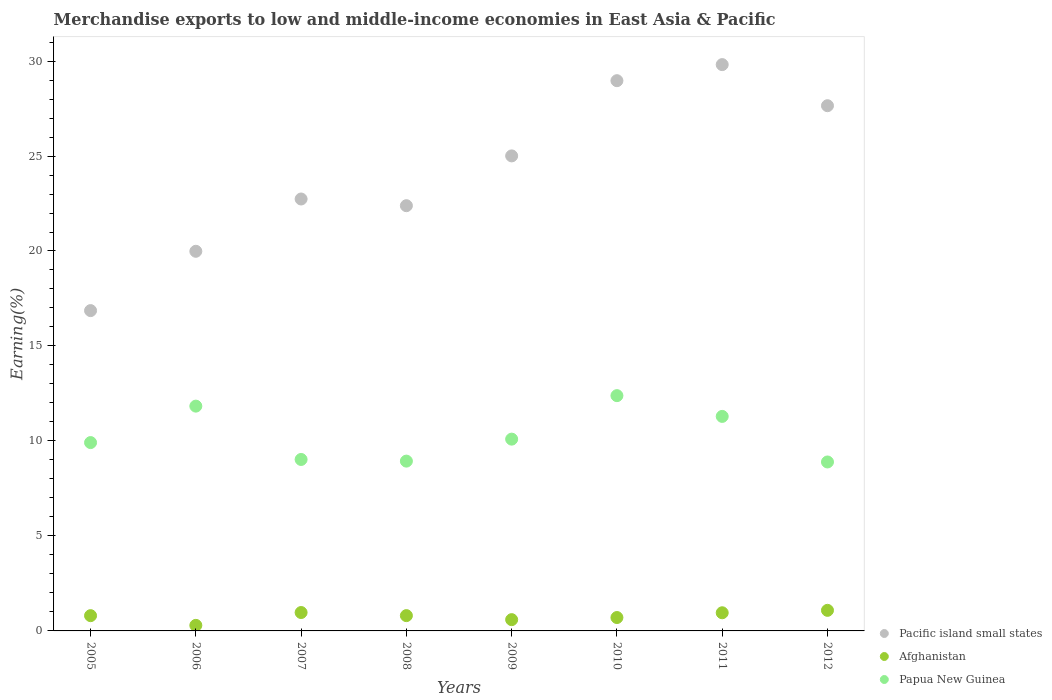How many different coloured dotlines are there?
Provide a succinct answer. 3. What is the percentage of amount earned from merchandise exports in Afghanistan in 2006?
Your answer should be very brief. 0.29. Across all years, what is the maximum percentage of amount earned from merchandise exports in Afghanistan?
Keep it short and to the point. 1.08. Across all years, what is the minimum percentage of amount earned from merchandise exports in Pacific island small states?
Make the answer very short. 16.86. In which year was the percentage of amount earned from merchandise exports in Papua New Guinea maximum?
Offer a terse response. 2010. In which year was the percentage of amount earned from merchandise exports in Afghanistan minimum?
Provide a short and direct response. 2006. What is the total percentage of amount earned from merchandise exports in Pacific island small states in the graph?
Your answer should be very brief. 193.4. What is the difference between the percentage of amount earned from merchandise exports in Pacific island small states in 2006 and that in 2009?
Ensure brevity in your answer.  -5.02. What is the difference between the percentage of amount earned from merchandise exports in Papua New Guinea in 2008 and the percentage of amount earned from merchandise exports in Pacific island small states in 2009?
Give a very brief answer. -16.07. What is the average percentage of amount earned from merchandise exports in Afghanistan per year?
Offer a terse response. 0.78. In the year 2007, what is the difference between the percentage of amount earned from merchandise exports in Afghanistan and percentage of amount earned from merchandise exports in Papua New Guinea?
Offer a terse response. -8.06. What is the ratio of the percentage of amount earned from merchandise exports in Papua New Guinea in 2006 to that in 2011?
Your answer should be very brief. 1.05. What is the difference between the highest and the second highest percentage of amount earned from merchandise exports in Pacific island small states?
Ensure brevity in your answer.  0.85. What is the difference between the highest and the lowest percentage of amount earned from merchandise exports in Pacific island small states?
Your response must be concise. 12.95. Is the sum of the percentage of amount earned from merchandise exports in Afghanistan in 2005 and 2010 greater than the maximum percentage of amount earned from merchandise exports in Papua New Guinea across all years?
Provide a succinct answer. No. Is it the case that in every year, the sum of the percentage of amount earned from merchandise exports in Afghanistan and percentage of amount earned from merchandise exports in Papua New Guinea  is greater than the percentage of amount earned from merchandise exports in Pacific island small states?
Provide a short and direct response. No. Does the percentage of amount earned from merchandise exports in Papua New Guinea monotonically increase over the years?
Your answer should be very brief. No. How many dotlines are there?
Provide a short and direct response. 3. How many years are there in the graph?
Provide a succinct answer. 8. Are the values on the major ticks of Y-axis written in scientific E-notation?
Offer a very short reply. No. Does the graph contain any zero values?
Offer a very short reply. No. Where does the legend appear in the graph?
Ensure brevity in your answer.  Bottom right. How many legend labels are there?
Offer a very short reply. 3. How are the legend labels stacked?
Your answer should be compact. Vertical. What is the title of the graph?
Give a very brief answer. Merchandise exports to low and middle-income economies in East Asia & Pacific. Does "Eritrea" appear as one of the legend labels in the graph?
Make the answer very short. No. What is the label or title of the X-axis?
Ensure brevity in your answer.  Years. What is the label or title of the Y-axis?
Ensure brevity in your answer.  Earning(%). What is the Earning(%) of Pacific island small states in 2005?
Provide a short and direct response. 16.86. What is the Earning(%) of Afghanistan in 2005?
Give a very brief answer. 0.8. What is the Earning(%) of Papua New Guinea in 2005?
Your response must be concise. 9.91. What is the Earning(%) in Pacific island small states in 2006?
Keep it short and to the point. 19.98. What is the Earning(%) in Afghanistan in 2006?
Provide a short and direct response. 0.29. What is the Earning(%) in Papua New Guinea in 2006?
Provide a short and direct response. 11.83. What is the Earning(%) in Pacific island small states in 2007?
Give a very brief answer. 22.74. What is the Earning(%) of Afghanistan in 2007?
Offer a very short reply. 0.97. What is the Earning(%) of Papua New Guinea in 2007?
Keep it short and to the point. 9.03. What is the Earning(%) of Pacific island small states in 2008?
Provide a short and direct response. 22.39. What is the Earning(%) of Afghanistan in 2008?
Keep it short and to the point. 0.81. What is the Earning(%) in Papua New Guinea in 2008?
Your response must be concise. 8.94. What is the Earning(%) in Pacific island small states in 2009?
Make the answer very short. 25.01. What is the Earning(%) of Afghanistan in 2009?
Give a very brief answer. 0.59. What is the Earning(%) of Papua New Guinea in 2009?
Ensure brevity in your answer.  10.1. What is the Earning(%) of Pacific island small states in 2010?
Make the answer very short. 28.97. What is the Earning(%) of Afghanistan in 2010?
Your response must be concise. 0.7. What is the Earning(%) of Papua New Guinea in 2010?
Provide a short and direct response. 12.39. What is the Earning(%) in Pacific island small states in 2011?
Make the answer very short. 29.81. What is the Earning(%) in Afghanistan in 2011?
Make the answer very short. 0.96. What is the Earning(%) in Papua New Guinea in 2011?
Offer a terse response. 11.29. What is the Earning(%) of Pacific island small states in 2012?
Make the answer very short. 27.65. What is the Earning(%) in Afghanistan in 2012?
Ensure brevity in your answer.  1.08. What is the Earning(%) in Papua New Guinea in 2012?
Your response must be concise. 8.89. Across all years, what is the maximum Earning(%) in Pacific island small states?
Your response must be concise. 29.81. Across all years, what is the maximum Earning(%) in Afghanistan?
Make the answer very short. 1.08. Across all years, what is the maximum Earning(%) in Papua New Guinea?
Your answer should be very brief. 12.39. Across all years, what is the minimum Earning(%) of Pacific island small states?
Give a very brief answer. 16.86. Across all years, what is the minimum Earning(%) in Afghanistan?
Give a very brief answer. 0.29. Across all years, what is the minimum Earning(%) in Papua New Guinea?
Give a very brief answer. 8.89. What is the total Earning(%) of Pacific island small states in the graph?
Keep it short and to the point. 193.4. What is the total Earning(%) in Afghanistan in the graph?
Make the answer very short. 6.21. What is the total Earning(%) in Papua New Guinea in the graph?
Your response must be concise. 82.38. What is the difference between the Earning(%) of Pacific island small states in 2005 and that in 2006?
Offer a terse response. -3.12. What is the difference between the Earning(%) in Afghanistan in 2005 and that in 2006?
Offer a very short reply. 0.51. What is the difference between the Earning(%) of Papua New Guinea in 2005 and that in 2006?
Make the answer very short. -1.92. What is the difference between the Earning(%) in Pacific island small states in 2005 and that in 2007?
Offer a very short reply. -5.88. What is the difference between the Earning(%) of Afghanistan in 2005 and that in 2007?
Keep it short and to the point. -0.16. What is the difference between the Earning(%) in Papua New Guinea in 2005 and that in 2007?
Your answer should be compact. 0.89. What is the difference between the Earning(%) in Pacific island small states in 2005 and that in 2008?
Offer a terse response. -5.52. What is the difference between the Earning(%) in Afghanistan in 2005 and that in 2008?
Offer a terse response. -0. What is the difference between the Earning(%) in Papua New Guinea in 2005 and that in 2008?
Your answer should be very brief. 0.98. What is the difference between the Earning(%) in Pacific island small states in 2005 and that in 2009?
Your response must be concise. -8.14. What is the difference between the Earning(%) of Afghanistan in 2005 and that in 2009?
Provide a succinct answer. 0.21. What is the difference between the Earning(%) of Papua New Guinea in 2005 and that in 2009?
Ensure brevity in your answer.  -0.18. What is the difference between the Earning(%) of Pacific island small states in 2005 and that in 2010?
Your response must be concise. -12.1. What is the difference between the Earning(%) of Afghanistan in 2005 and that in 2010?
Offer a very short reply. 0.1. What is the difference between the Earning(%) in Papua New Guinea in 2005 and that in 2010?
Ensure brevity in your answer.  -2.47. What is the difference between the Earning(%) in Pacific island small states in 2005 and that in 2011?
Your answer should be very brief. -12.95. What is the difference between the Earning(%) in Afghanistan in 2005 and that in 2011?
Give a very brief answer. -0.15. What is the difference between the Earning(%) in Papua New Guinea in 2005 and that in 2011?
Make the answer very short. -1.38. What is the difference between the Earning(%) of Pacific island small states in 2005 and that in 2012?
Offer a terse response. -10.79. What is the difference between the Earning(%) in Afghanistan in 2005 and that in 2012?
Your answer should be very brief. -0.28. What is the difference between the Earning(%) of Papua New Guinea in 2005 and that in 2012?
Make the answer very short. 1.02. What is the difference between the Earning(%) in Pacific island small states in 2006 and that in 2007?
Make the answer very short. -2.75. What is the difference between the Earning(%) of Afghanistan in 2006 and that in 2007?
Provide a succinct answer. -0.68. What is the difference between the Earning(%) in Papua New Guinea in 2006 and that in 2007?
Your answer should be compact. 2.81. What is the difference between the Earning(%) in Pacific island small states in 2006 and that in 2008?
Your response must be concise. -2.4. What is the difference between the Earning(%) of Afghanistan in 2006 and that in 2008?
Your response must be concise. -0.51. What is the difference between the Earning(%) of Papua New Guinea in 2006 and that in 2008?
Give a very brief answer. 2.89. What is the difference between the Earning(%) of Pacific island small states in 2006 and that in 2009?
Offer a very short reply. -5.02. What is the difference between the Earning(%) of Afghanistan in 2006 and that in 2009?
Make the answer very short. -0.3. What is the difference between the Earning(%) of Papua New Guinea in 2006 and that in 2009?
Offer a very short reply. 1.74. What is the difference between the Earning(%) of Pacific island small states in 2006 and that in 2010?
Ensure brevity in your answer.  -8.98. What is the difference between the Earning(%) in Afghanistan in 2006 and that in 2010?
Give a very brief answer. -0.41. What is the difference between the Earning(%) of Papua New Guinea in 2006 and that in 2010?
Your response must be concise. -0.55. What is the difference between the Earning(%) in Pacific island small states in 2006 and that in 2011?
Ensure brevity in your answer.  -9.83. What is the difference between the Earning(%) of Afghanistan in 2006 and that in 2011?
Your answer should be compact. -0.66. What is the difference between the Earning(%) of Papua New Guinea in 2006 and that in 2011?
Give a very brief answer. 0.54. What is the difference between the Earning(%) in Pacific island small states in 2006 and that in 2012?
Your answer should be compact. -7.66. What is the difference between the Earning(%) of Afghanistan in 2006 and that in 2012?
Make the answer very short. -0.79. What is the difference between the Earning(%) in Papua New Guinea in 2006 and that in 2012?
Provide a short and direct response. 2.94. What is the difference between the Earning(%) of Pacific island small states in 2007 and that in 2008?
Offer a very short reply. 0.35. What is the difference between the Earning(%) in Afghanistan in 2007 and that in 2008?
Make the answer very short. 0.16. What is the difference between the Earning(%) of Papua New Guinea in 2007 and that in 2008?
Ensure brevity in your answer.  0.09. What is the difference between the Earning(%) of Pacific island small states in 2007 and that in 2009?
Provide a succinct answer. -2.27. What is the difference between the Earning(%) in Afghanistan in 2007 and that in 2009?
Your response must be concise. 0.37. What is the difference between the Earning(%) in Papua New Guinea in 2007 and that in 2009?
Make the answer very short. -1.07. What is the difference between the Earning(%) of Pacific island small states in 2007 and that in 2010?
Provide a short and direct response. -6.23. What is the difference between the Earning(%) in Afghanistan in 2007 and that in 2010?
Provide a succinct answer. 0.26. What is the difference between the Earning(%) in Papua New Guinea in 2007 and that in 2010?
Your answer should be very brief. -3.36. What is the difference between the Earning(%) in Pacific island small states in 2007 and that in 2011?
Give a very brief answer. -7.07. What is the difference between the Earning(%) of Afghanistan in 2007 and that in 2011?
Give a very brief answer. 0.01. What is the difference between the Earning(%) in Papua New Guinea in 2007 and that in 2011?
Provide a short and direct response. -2.27. What is the difference between the Earning(%) of Pacific island small states in 2007 and that in 2012?
Provide a short and direct response. -4.91. What is the difference between the Earning(%) of Afghanistan in 2007 and that in 2012?
Your answer should be very brief. -0.12. What is the difference between the Earning(%) of Papua New Guinea in 2007 and that in 2012?
Make the answer very short. 0.13. What is the difference between the Earning(%) in Pacific island small states in 2008 and that in 2009?
Provide a succinct answer. -2.62. What is the difference between the Earning(%) of Afghanistan in 2008 and that in 2009?
Your answer should be very brief. 0.21. What is the difference between the Earning(%) of Papua New Guinea in 2008 and that in 2009?
Make the answer very short. -1.16. What is the difference between the Earning(%) of Pacific island small states in 2008 and that in 2010?
Your answer should be compact. -6.58. What is the difference between the Earning(%) of Afghanistan in 2008 and that in 2010?
Ensure brevity in your answer.  0.1. What is the difference between the Earning(%) of Papua New Guinea in 2008 and that in 2010?
Keep it short and to the point. -3.45. What is the difference between the Earning(%) in Pacific island small states in 2008 and that in 2011?
Offer a very short reply. -7.43. What is the difference between the Earning(%) of Afghanistan in 2008 and that in 2011?
Your answer should be very brief. -0.15. What is the difference between the Earning(%) of Papua New Guinea in 2008 and that in 2011?
Ensure brevity in your answer.  -2.35. What is the difference between the Earning(%) of Pacific island small states in 2008 and that in 2012?
Keep it short and to the point. -5.26. What is the difference between the Earning(%) of Afghanistan in 2008 and that in 2012?
Keep it short and to the point. -0.28. What is the difference between the Earning(%) of Papua New Guinea in 2008 and that in 2012?
Provide a short and direct response. 0.04. What is the difference between the Earning(%) of Pacific island small states in 2009 and that in 2010?
Your answer should be compact. -3.96. What is the difference between the Earning(%) in Afghanistan in 2009 and that in 2010?
Your answer should be very brief. -0.11. What is the difference between the Earning(%) in Papua New Guinea in 2009 and that in 2010?
Ensure brevity in your answer.  -2.29. What is the difference between the Earning(%) in Pacific island small states in 2009 and that in 2011?
Ensure brevity in your answer.  -4.81. What is the difference between the Earning(%) of Afghanistan in 2009 and that in 2011?
Provide a short and direct response. -0.36. What is the difference between the Earning(%) of Papua New Guinea in 2009 and that in 2011?
Offer a terse response. -1.2. What is the difference between the Earning(%) of Pacific island small states in 2009 and that in 2012?
Your answer should be very brief. -2.64. What is the difference between the Earning(%) in Afghanistan in 2009 and that in 2012?
Your response must be concise. -0.49. What is the difference between the Earning(%) of Papua New Guinea in 2009 and that in 2012?
Keep it short and to the point. 1.2. What is the difference between the Earning(%) of Pacific island small states in 2010 and that in 2011?
Offer a terse response. -0.85. What is the difference between the Earning(%) in Afghanistan in 2010 and that in 2011?
Make the answer very short. -0.25. What is the difference between the Earning(%) in Papua New Guinea in 2010 and that in 2011?
Offer a very short reply. 1.09. What is the difference between the Earning(%) of Pacific island small states in 2010 and that in 2012?
Offer a terse response. 1.32. What is the difference between the Earning(%) in Afghanistan in 2010 and that in 2012?
Offer a terse response. -0.38. What is the difference between the Earning(%) of Papua New Guinea in 2010 and that in 2012?
Your response must be concise. 3.49. What is the difference between the Earning(%) in Pacific island small states in 2011 and that in 2012?
Give a very brief answer. 2.16. What is the difference between the Earning(%) in Afghanistan in 2011 and that in 2012?
Your response must be concise. -0.13. What is the difference between the Earning(%) in Papua New Guinea in 2011 and that in 2012?
Provide a succinct answer. 2.4. What is the difference between the Earning(%) in Pacific island small states in 2005 and the Earning(%) in Afghanistan in 2006?
Your answer should be very brief. 16.57. What is the difference between the Earning(%) in Pacific island small states in 2005 and the Earning(%) in Papua New Guinea in 2006?
Provide a succinct answer. 5.03. What is the difference between the Earning(%) in Afghanistan in 2005 and the Earning(%) in Papua New Guinea in 2006?
Offer a very short reply. -11.03. What is the difference between the Earning(%) in Pacific island small states in 2005 and the Earning(%) in Afghanistan in 2007?
Make the answer very short. 15.89. What is the difference between the Earning(%) of Pacific island small states in 2005 and the Earning(%) of Papua New Guinea in 2007?
Give a very brief answer. 7.84. What is the difference between the Earning(%) of Afghanistan in 2005 and the Earning(%) of Papua New Guinea in 2007?
Give a very brief answer. -8.22. What is the difference between the Earning(%) of Pacific island small states in 2005 and the Earning(%) of Afghanistan in 2008?
Keep it short and to the point. 16.06. What is the difference between the Earning(%) in Pacific island small states in 2005 and the Earning(%) in Papua New Guinea in 2008?
Your answer should be compact. 7.92. What is the difference between the Earning(%) of Afghanistan in 2005 and the Earning(%) of Papua New Guinea in 2008?
Offer a terse response. -8.14. What is the difference between the Earning(%) in Pacific island small states in 2005 and the Earning(%) in Afghanistan in 2009?
Your response must be concise. 16.27. What is the difference between the Earning(%) of Pacific island small states in 2005 and the Earning(%) of Papua New Guinea in 2009?
Ensure brevity in your answer.  6.77. What is the difference between the Earning(%) in Afghanistan in 2005 and the Earning(%) in Papua New Guinea in 2009?
Give a very brief answer. -9.29. What is the difference between the Earning(%) of Pacific island small states in 2005 and the Earning(%) of Afghanistan in 2010?
Your response must be concise. 16.16. What is the difference between the Earning(%) of Pacific island small states in 2005 and the Earning(%) of Papua New Guinea in 2010?
Provide a short and direct response. 4.48. What is the difference between the Earning(%) of Afghanistan in 2005 and the Earning(%) of Papua New Guinea in 2010?
Keep it short and to the point. -11.58. What is the difference between the Earning(%) in Pacific island small states in 2005 and the Earning(%) in Afghanistan in 2011?
Provide a short and direct response. 15.91. What is the difference between the Earning(%) of Pacific island small states in 2005 and the Earning(%) of Papua New Guinea in 2011?
Offer a terse response. 5.57. What is the difference between the Earning(%) in Afghanistan in 2005 and the Earning(%) in Papua New Guinea in 2011?
Keep it short and to the point. -10.49. What is the difference between the Earning(%) of Pacific island small states in 2005 and the Earning(%) of Afghanistan in 2012?
Your response must be concise. 15.78. What is the difference between the Earning(%) of Pacific island small states in 2005 and the Earning(%) of Papua New Guinea in 2012?
Your answer should be compact. 7.97. What is the difference between the Earning(%) in Afghanistan in 2005 and the Earning(%) in Papua New Guinea in 2012?
Give a very brief answer. -8.09. What is the difference between the Earning(%) in Pacific island small states in 2006 and the Earning(%) in Afghanistan in 2007?
Offer a very short reply. 19.02. What is the difference between the Earning(%) of Pacific island small states in 2006 and the Earning(%) of Papua New Guinea in 2007?
Your answer should be very brief. 10.96. What is the difference between the Earning(%) of Afghanistan in 2006 and the Earning(%) of Papua New Guinea in 2007?
Your response must be concise. -8.73. What is the difference between the Earning(%) in Pacific island small states in 2006 and the Earning(%) in Afghanistan in 2008?
Offer a very short reply. 19.18. What is the difference between the Earning(%) in Pacific island small states in 2006 and the Earning(%) in Papua New Guinea in 2008?
Keep it short and to the point. 11.05. What is the difference between the Earning(%) of Afghanistan in 2006 and the Earning(%) of Papua New Guinea in 2008?
Provide a short and direct response. -8.65. What is the difference between the Earning(%) of Pacific island small states in 2006 and the Earning(%) of Afghanistan in 2009?
Ensure brevity in your answer.  19.39. What is the difference between the Earning(%) of Pacific island small states in 2006 and the Earning(%) of Papua New Guinea in 2009?
Your answer should be compact. 9.89. What is the difference between the Earning(%) of Afghanistan in 2006 and the Earning(%) of Papua New Guinea in 2009?
Ensure brevity in your answer.  -9.8. What is the difference between the Earning(%) in Pacific island small states in 2006 and the Earning(%) in Afghanistan in 2010?
Offer a very short reply. 19.28. What is the difference between the Earning(%) of Pacific island small states in 2006 and the Earning(%) of Papua New Guinea in 2010?
Give a very brief answer. 7.6. What is the difference between the Earning(%) of Afghanistan in 2006 and the Earning(%) of Papua New Guinea in 2010?
Offer a terse response. -12.09. What is the difference between the Earning(%) in Pacific island small states in 2006 and the Earning(%) in Afghanistan in 2011?
Your response must be concise. 19.03. What is the difference between the Earning(%) of Pacific island small states in 2006 and the Earning(%) of Papua New Guinea in 2011?
Your answer should be compact. 8.69. What is the difference between the Earning(%) of Afghanistan in 2006 and the Earning(%) of Papua New Guinea in 2011?
Offer a very short reply. -11. What is the difference between the Earning(%) in Pacific island small states in 2006 and the Earning(%) in Afghanistan in 2012?
Provide a short and direct response. 18.9. What is the difference between the Earning(%) in Pacific island small states in 2006 and the Earning(%) in Papua New Guinea in 2012?
Offer a terse response. 11.09. What is the difference between the Earning(%) in Afghanistan in 2006 and the Earning(%) in Papua New Guinea in 2012?
Provide a short and direct response. -8.6. What is the difference between the Earning(%) of Pacific island small states in 2007 and the Earning(%) of Afghanistan in 2008?
Ensure brevity in your answer.  21.93. What is the difference between the Earning(%) in Pacific island small states in 2007 and the Earning(%) in Papua New Guinea in 2008?
Provide a short and direct response. 13.8. What is the difference between the Earning(%) in Afghanistan in 2007 and the Earning(%) in Papua New Guinea in 2008?
Ensure brevity in your answer.  -7.97. What is the difference between the Earning(%) of Pacific island small states in 2007 and the Earning(%) of Afghanistan in 2009?
Give a very brief answer. 22.14. What is the difference between the Earning(%) in Pacific island small states in 2007 and the Earning(%) in Papua New Guinea in 2009?
Offer a very short reply. 12.64. What is the difference between the Earning(%) of Afghanistan in 2007 and the Earning(%) of Papua New Guinea in 2009?
Your answer should be compact. -9.13. What is the difference between the Earning(%) in Pacific island small states in 2007 and the Earning(%) in Afghanistan in 2010?
Offer a very short reply. 22.03. What is the difference between the Earning(%) in Pacific island small states in 2007 and the Earning(%) in Papua New Guinea in 2010?
Provide a succinct answer. 10.35. What is the difference between the Earning(%) of Afghanistan in 2007 and the Earning(%) of Papua New Guinea in 2010?
Make the answer very short. -11.42. What is the difference between the Earning(%) of Pacific island small states in 2007 and the Earning(%) of Afghanistan in 2011?
Ensure brevity in your answer.  21.78. What is the difference between the Earning(%) of Pacific island small states in 2007 and the Earning(%) of Papua New Guinea in 2011?
Offer a very short reply. 11.44. What is the difference between the Earning(%) of Afghanistan in 2007 and the Earning(%) of Papua New Guinea in 2011?
Provide a short and direct response. -10.32. What is the difference between the Earning(%) of Pacific island small states in 2007 and the Earning(%) of Afghanistan in 2012?
Your response must be concise. 21.65. What is the difference between the Earning(%) of Pacific island small states in 2007 and the Earning(%) of Papua New Guinea in 2012?
Provide a succinct answer. 13.84. What is the difference between the Earning(%) in Afghanistan in 2007 and the Earning(%) in Papua New Guinea in 2012?
Offer a very short reply. -7.93. What is the difference between the Earning(%) of Pacific island small states in 2008 and the Earning(%) of Afghanistan in 2009?
Give a very brief answer. 21.79. What is the difference between the Earning(%) in Pacific island small states in 2008 and the Earning(%) in Papua New Guinea in 2009?
Provide a short and direct response. 12.29. What is the difference between the Earning(%) in Afghanistan in 2008 and the Earning(%) in Papua New Guinea in 2009?
Ensure brevity in your answer.  -9.29. What is the difference between the Earning(%) of Pacific island small states in 2008 and the Earning(%) of Afghanistan in 2010?
Offer a terse response. 21.68. What is the difference between the Earning(%) in Pacific island small states in 2008 and the Earning(%) in Papua New Guinea in 2010?
Offer a terse response. 10. What is the difference between the Earning(%) of Afghanistan in 2008 and the Earning(%) of Papua New Guinea in 2010?
Provide a short and direct response. -11.58. What is the difference between the Earning(%) in Pacific island small states in 2008 and the Earning(%) in Afghanistan in 2011?
Ensure brevity in your answer.  21.43. What is the difference between the Earning(%) of Pacific island small states in 2008 and the Earning(%) of Papua New Guinea in 2011?
Your answer should be very brief. 11.09. What is the difference between the Earning(%) of Afghanistan in 2008 and the Earning(%) of Papua New Guinea in 2011?
Offer a very short reply. -10.49. What is the difference between the Earning(%) of Pacific island small states in 2008 and the Earning(%) of Afghanistan in 2012?
Offer a terse response. 21.3. What is the difference between the Earning(%) of Pacific island small states in 2008 and the Earning(%) of Papua New Guinea in 2012?
Provide a succinct answer. 13.49. What is the difference between the Earning(%) of Afghanistan in 2008 and the Earning(%) of Papua New Guinea in 2012?
Offer a very short reply. -8.09. What is the difference between the Earning(%) of Pacific island small states in 2009 and the Earning(%) of Afghanistan in 2010?
Your answer should be compact. 24.3. What is the difference between the Earning(%) in Pacific island small states in 2009 and the Earning(%) in Papua New Guinea in 2010?
Keep it short and to the point. 12.62. What is the difference between the Earning(%) in Afghanistan in 2009 and the Earning(%) in Papua New Guinea in 2010?
Your response must be concise. -11.79. What is the difference between the Earning(%) of Pacific island small states in 2009 and the Earning(%) of Afghanistan in 2011?
Your answer should be very brief. 24.05. What is the difference between the Earning(%) of Pacific island small states in 2009 and the Earning(%) of Papua New Guinea in 2011?
Ensure brevity in your answer.  13.71. What is the difference between the Earning(%) of Afghanistan in 2009 and the Earning(%) of Papua New Guinea in 2011?
Your response must be concise. -10.7. What is the difference between the Earning(%) in Pacific island small states in 2009 and the Earning(%) in Afghanistan in 2012?
Make the answer very short. 23.92. What is the difference between the Earning(%) in Pacific island small states in 2009 and the Earning(%) in Papua New Guinea in 2012?
Offer a very short reply. 16.11. What is the difference between the Earning(%) in Afghanistan in 2009 and the Earning(%) in Papua New Guinea in 2012?
Offer a very short reply. -8.3. What is the difference between the Earning(%) in Pacific island small states in 2010 and the Earning(%) in Afghanistan in 2011?
Make the answer very short. 28.01. What is the difference between the Earning(%) of Pacific island small states in 2010 and the Earning(%) of Papua New Guinea in 2011?
Make the answer very short. 17.67. What is the difference between the Earning(%) in Afghanistan in 2010 and the Earning(%) in Papua New Guinea in 2011?
Keep it short and to the point. -10.59. What is the difference between the Earning(%) in Pacific island small states in 2010 and the Earning(%) in Afghanistan in 2012?
Give a very brief answer. 27.88. What is the difference between the Earning(%) of Pacific island small states in 2010 and the Earning(%) of Papua New Guinea in 2012?
Make the answer very short. 20.07. What is the difference between the Earning(%) of Afghanistan in 2010 and the Earning(%) of Papua New Guinea in 2012?
Give a very brief answer. -8.19. What is the difference between the Earning(%) of Pacific island small states in 2011 and the Earning(%) of Afghanistan in 2012?
Your answer should be very brief. 28.73. What is the difference between the Earning(%) in Pacific island small states in 2011 and the Earning(%) in Papua New Guinea in 2012?
Ensure brevity in your answer.  20.92. What is the difference between the Earning(%) in Afghanistan in 2011 and the Earning(%) in Papua New Guinea in 2012?
Your answer should be compact. -7.94. What is the average Earning(%) in Pacific island small states per year?
Your answer should be compact. 24.18. What is the average Earning(%) of Afghanistan per year?
Ensure brevity in your answer.  0.78. What is the average Earning(%) of Papua New Guinea per year?
Your response must be concise. 10.3. In the year 2005, what is the difference between the Earning(%) in Pacific island small states and Earning(%) in Afghanistan?
Ensure brevity in your answer.  16.06. In the year 2005, what is the difference between the Earning(%) of Pacific island small states and Earning(%) of Papua New Guinea?
Give a very brief answer. 6.95. In the year 2005, what is the difference between the Earning(%) in Afghanistan and Earning(%) in Papua New Guinea?
Offer a terse response. -9.11. In the year 2006, what is the difference between the Earning(%) of Pacific island small states and Earning(%) of Afghanistan?
Give a very brief answer. 19.69. In the year 2006, what is the difference between the Earning(%) in Pacific island small states and Earning(%) in Papua New Guinea?
Give a very brief answer. 8.15. In the year 2006, what is the difference between the Earning(%) in Afghanistan and Earning(%) in Papua New Guinea?
Keep it short and to the point. -11.54. In the year 2007, what is the difference between the Earning(%) of Pacific island small states and Earning(%) of Afghanistan?
Keep it short and to the point. 21.77. In the year 2007, what is the difference between the Earning(%) of Pacific island small states and Earning(%) of Papua New Guinea?
Your answer should be very brief. 13.71. In the year 2007, what is the difference between the Earning(%) in Afghanistan and Earning(%) in Papua New Guinea?
Give a very brief answer. -8.06. In the year 2008, what is the difference between the Earning(%) of Pacific island small states and Earning(%) of Afghanistan?
Keep it short and to the point. 21.58. In the year 2008, what is the difference between the Earning(%) of Pacific island small states and Earning(%) of Papua New Guinea?
Your response must be concise. 13.45. In the year 2008, what is the difference between the Earning(%) of Afghanistan and Earning(%) of Papua New Guinea?
Give a very brief answer. -8.13. In the year 2009, what is the difference between the Earning(%) of Pacific island small states and Earning(%) of Afghanistan?
Provide a succinct answer. 24.41. In the year 2009, what is the difference between the Earning(%) of Pacific island small states and Earning(%) of Papua New Guinea?
Your answer should be very brief. 14.91. In the year 2009, what is the difference between the Earning(%) of Afghanistan and Earning(%) of Papua New Guinea?
Make the answer very short. -9.5. In the year 2010, what is the difference between the Earning(%) of Pacific island small states and Earning(%) of Afghanistan?
Keep it short and to the point. 28.26. In the year 2010, what is the difference between the Earning(%) of Pacific island small states and Earning(%) of Papua New Guinea?
Give a very brief answer. 16.58. In the year 2010, what is the difference between the Earning(%) in Afghanistan and Earning(%) in Papua New Guinea?
Offer a very short reply. -11.68. In the year 2011, what is the difference between the Earning(%) of Pacific island small states and Earning(%) of Afghanistan?
Give a very brief answer. 28.86. In the year 2011, what is the difference between the Earning(%) of Pacific island small states and Earning(%) of Papua New Guinea?
Provide a short and direct response. 18.52. In the year 2011, what is the difference between the Earning(%) in Afghanistan and Earning(%) in Papua New Guinea?
Provide a succinct answer. -10.34. In the year 2012, what is the difference between the Earning(%) in Pacific island small states and Earning(%) in Afghanistan?
Your answer should be compact. 26.57. In the year 2012, what is the difference between the Earning(%) in Pacific island small states and Earning(%) in Papua New Guinea?
Offer a very short reply. 18.75. In the year 2012, what is the difference between the Earning(%) of Afghanistan and Earning(%) of Papua New Guinea?
Your answer should be compact. -7.81. What is the ratio of the Earning(%) of Pacific island small states in 2005 to that in 2006?
Ensure brevity in your answer.  0.84. What is the ratio of the Earning(%) in Afghanistan in 2005 to that in 2006?
Keep it short and to the point. 2.74. What is the ratio of the Earning(%) in Papua New Guinea in 2005 to that in 2006?
Provide a short and direct response. 0.84. What is the ratio of the Earning(%) of Pacific island small states in 2005 to that in 2007?
Your response must be concise. 0.74. What is the ratio of the Earning(%) of Afghanistan in 2005 to that in 2007?
Ensure brevity in your answer.  0.83. What is the ratio of the Earning(%) of Papua New Guinea in 2005 to that in 2007?
Your answer should be compact. 1.1. What is the ratio of the Earning(%) in Pacific island small states in 2005 to that in 2008?
Keep it short and to the point. 0.75. What is the ratio of the Earning(%) of Papua New Guinea in 2005 to that in 2008?
Your answer should be compact. 1.11. What is the ratio of the Earning(%) in Pacific island small states in 2005 to that in 2009?
Make the answer very short. 0.67. What is the ratio of the Earning(%) in Afghanistan in 2005 to that in 2009?
Your response must be concise. 1.35. What is the ratio of the Earning(%) in Pacific island small states in 2005 to that in 2010?
Your answer should be very brief. 0.58. What is the ratio of the Earning(%) of Afghanistan in 2005 to that in 2010?
Offer a very short reply. 1.14. What is the ratio of the Earning(%) in Papua New Guinea in 2005 to that in 2010?
Offer a terse response. 0.8. What is the ratio of the Earning(%) in Pacific island small states in 2005 to that in 2011?
Ensure brevity in your answer.  0.57. What is the ratio of the Earning(%) in Afghanistan in 2005 to that in 2011?
Make the answer very short. 0.84. What is the ratio of the Earning(%) of Papua New Guinea in 2005 to that in 2011?
Provide a short and direct response. 0.88. What is the ratio of the Earning(%) of Pacific island small states in 2005 to that in 2012?
Make the answer very short. 0.61. What is the ratio of the Earning(%) of Afghanistan in 2005 to that in 2012?
Ensure brevity in your answer.  0.74. What is the ratio of the Earning(%) in Papua New Guinea in 2005 to that in 2012?
Your answer should be very brief. 1.11. What is the ratio of the Earning(%) of Pacific island small states in 2006 to that in 2007?
Provide a short and direct response. 0.88. What is the ratio of the Earning(%) of Afghanistan in 2006 to that in 2007?
Give a very brief answer. 0.3. What is the ratio of the Earning(%) in Papua New Guinea in 2006 to that in 2007?
Your response must be concise. 1.31. What is the ratio of the Earning(%) in Pacific island small states in 2006 to that in 2008?
Provide a short and direct response. 0.89. What is the ratio of the Earning(%) in Afghanistan in 2006 to that in 2008?
Your answer should be compact. 0.36. What is the ratio of the Earning(%) of Papua New Guinea in 2006 to that in 2008?
Make the answer very short. 1.32. What is the ratio of the Earning(%) in Pacific island small states in 2006 to that in 2009?
Your response must be concise. 0.8. What is the ratio of the Earning(%) in Afghanistan in 2006 to that in 2009?
Provide a short and direct response. 0.49. What is the ratio of the Earning(%) of Papua New Guinea in 2006 to that in 2009?
Offer a terse response. 1.17. What is the ratio of the Earning(%) of Pacific island small states in 2006 to that in 2010?
Provide a short and direct response. 0.69. What is the ratio of the Earning(%) of Afghanistan in 2006 to that in 2010?
Make the answer very short. 0.42. What is the ratio of the Earning(%) of Papua New Guinea in 2006 to that in 2010?
Offer a very short reply. 0.96. What is the ratio of the Earning(%) in Pacific island small states in 2006 to that in 2011?
Offer a terse response. 0.67. What is the ratio of the Earning(%) in Afghanistan in 2006 to that in 2011?
Your response must be concise. 0.31. What is the ratio of the Earning(%) in Papua New Guinea in 2006 to that in 2011?
Your answer should be compact. 1.05. What is the ratio of the Earning(%) in Pacific island small states in 2006 to that in 2012?
Provide a succinct answer. 0.72. What is the ratio of the Earning(%) of Afghanistan in 2006 to that in 2012?
Offer a very short reply. 0.27. What is the ratio of the Earning(%) in Papua New Guinea in 2006 to that in 2012?
Offer a very short reply. 1.33. What is the ratio of the Earning(%) of Pacific island small states in 2007 to that in 2008?
Your answer should be compact. 1.02. What is the ratio of the Earning(%) in Afghanistan in 2007 to that in 2008?
Give a very brief answer. 1.2. What is the ratio of the Earning(%) in Papua New Guinea in 2007 to that in 2008?
Keep it short and to the point. 1.01. What is the ratio of the Earning(%) of Pacific island small states in 2007 to that in 2009?
Provide a succinct answer. 0.91. What is the ratio of the Earning(%) in Afghanistan in 2007 to that in 2009?
Your answer should be compact. 1.63. What is the ratio of the Earning(%) of Papua New Guinea in 2007 to that in 2009?
Your answer should be compact. 0.89. What is the ratio of the Earning(%) in Pacific island small states in 2007 to that in 2010?
Offer a terse response. 0.79. What is the ratio of the Earning(%) of Afghanistan in 2007 to that in 2010?
Your answer should be very brief. 1.37. What is the ratio of the Earning(%) of Papua New Guinea in 2007 to that in 2010?
Provide a succinct answer. 0.73. What is the ratio of the Earning(%) in Pacific island small states in 2007 to that in 2011?
Ensure brevity in your answer.  0.76. What is the ratio of the Earning(%) in Afghanistan in 2007 to that in 2011?
Offer a terse response. 1.01. What is the ratio of the Earning(%) of Papua New Guinea in 2007 to that in 2011?
Keep it short and to the point. 0.8. What is the ratio of the Earning(%) in Pacific island small states in 2007 to that in 2012?
Make the answer very short. 0.82. What is the ratio of the Earning(%) in Afghanistan in 2007 to that in 2012?
Make the answer very short. 0.89. What is the ratio of the Earning(%) in Papua New Guinea in 2007 to that in 2012?
Provide a short and direct response. 1.01. What is the ratio of the Earning(%) of Pacific island small states in 2008 to that in 2009?
Offer a terse response. 0.9. What is the ratio of the Earning(%) of Afghanistan in 2008 to that in 2009?
Provide a succinct answer. 1.36. What is the ratio of the Earning(%) of Papua New Guinea in 2008 to that in 2009?
Your answer should be compact. 0.89. What is the ratio of the Earning(%) in Pacific island small states in 2008 to that in 2010?
Make the answer very short. 0.77. What is the ratio of the Earning(%) of Afghanistan in 2008 to that in 2010?
Provide a short and direct response. 1.14. What is the ratio of the Earning(%) of Papua New Guinea in 2008 to that in 2010?
Offer a very short reply. 0.72. What is the ratio of the Earning(%) of Pacific island small states in 2008 to that in 2011?
Provide a succinct answer. 0.75. What is the ratio of the Earning(%) in Afghanistan in 2008 to that in 2011?
Your answer should be compact. 0.84. What is the ratio of the Earning(%) of Papua New Guinea in 2008 to that in 2011?
Give a very brief answer. 0.79. What is the ratio of the Earning(%) of Pacific island small states in 2008 to that in 2012?
Your answer should be compact. 0.81. What is the ratio of the Earning(%) of Afghanistan in 2008 to that in 2012?
Ensure brevity in your answer.  0.74. What is the ratio of the Earning(%) of Pacific island small states in 2009 to that in 2010?
Offer a very short reply. 0.86. What is the ratio of the Earning(%) of Afghanistan in 2009 to that in 2010?
Make the answer very short. 0.84. What is the ratio of the Earning(%) in Papua New Guinea in 2009 to that in 2010?
Make the answer very short. 0.82. What is the ratio of the Earning(%) of Pacific island small states in 2009 to that in 2011?
Make the answer very short. 0.84. What is the ratio of the Earning(%) in Afghanistan in 2009 to that in 2011?
Offer a very short reply. 0.62. What is the ratio of the Earning(%) in Papua New Guinea in 2009 to that in 2011?
Provide a short and direct response. 0.89. What is the ratio of the Earning(%) of Pacific island small states in 2009 to that in 2012?
Provide a succinct answer. 0.9. What is the ratio of the Earning(%) in Afghanistan in 2009 to that in 2012?
Give a very brief answer. 0.55. What is the ratio of the Earning(%) of Papua New Guinea in 2009 to that in 2012?
Keep it short and to the point. 1.14. What is the ratio of the Earning(%) of Pacific island small states in 2010 to that in 2011?
Your answer should be very brief. 0.97. What is the ratio of the Earning(%) in Afghanistan in 2010 to that in 2011?
Offer a very short reply. 0.74. What is the ratio of the Earning(%) of Papua New Guinea in 2010 to that in 2011?
Offer a terse response. 1.1. What is the ratio of the Earning(%) in Pacific island small states in 2010 to that in 2012?
Offer a terse response. 1.05. What is the ratio of the Earning(%) of Afghanistan in 2010 to that in 2012?
Ensure brevity in your answer.  0.65. What is the ratio of the Earning(%) of Papua New Guinea in 2010 to that in 2012?
Make the answer very short. 1.39. What is the ratio of the Earning(%) in Pacific island small states in 2011 to that in 2012?
Your response must be concise. 1.08. What is the ratio of the Earning(%) of Afghanistan in 2011 to that in 2012?
Your answer should be very brief. 0.88. What is the ratio of the Earning(%) of Papua New Guinea in 2011 to that in 2012?
Your answer should be compact. 1.27. What is the difference between the highest and the second highest Earning(%) in Pacific island small states?
Make the answer very short. 0.85. What is the difference between the highest and the second highest Earning(%) in Afghanistan?
Your answer should be compact. 0.12. What is the difference between the highest and the second highest Earning(%) of Papua New Guinea?
Your answer should be compact. 0.55. What is the difference between the highest and the lowest Earning(%) in Pacific island small states?
Ensure brevity in your answer.  12.95. What is the difference between the highest and the lowest Earning(%) in Afghanistan?
Your response must be concise. 0.79. What is the difference between the highest and the lowest Earning(%) of Papua New Guinea?
Make the answer very short. 3.49. 